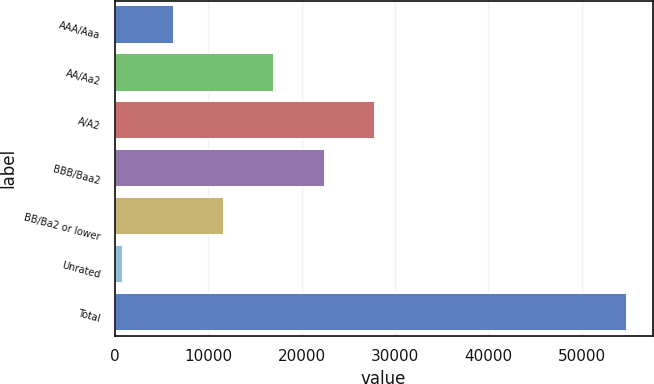Convert chart to OTSL. <chart><loc_0><loc_0><loc_500><loc_500><bar_chart><fcel>AAA/Aaa<fcel>AA/Aa2<fcel>A/A2<fcel>BBB/Baa2<fcel>BB/Ba2 or lower<fcel>Unrated<fcel>Total<nl><fcel>6317.2<fcel>17097.6<fcel>27878<fcel>22487.8<fcel>11707.4<fcel>927<fcel>54829<nl></chart> 